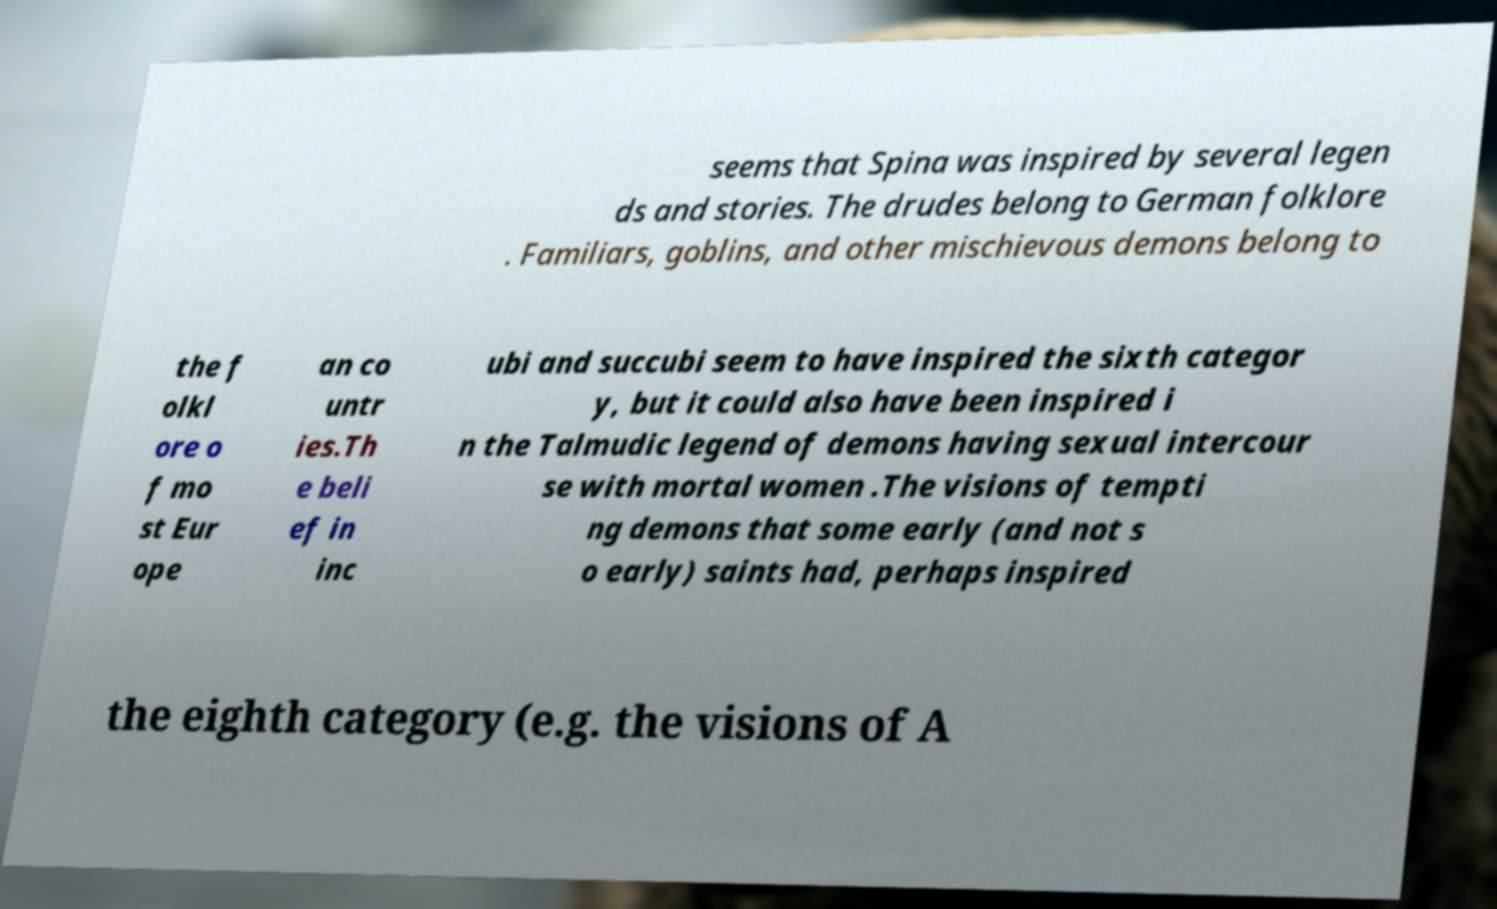I need the written content from this picture converted into text. Can you do that? seems that Spina was inspired by several legen ds and stories. The drudes belong to German folklore . Familiars, goblins, and other mischievous demons belong to the f olkl ore o f mo st Eur ope an co untr ies.Th e beli ef in inc ubi and succubi seem to have inspired the sixth categor y, but it could also have been inspired i n the Talmudic legend of demons having sexual intercour se with mortal women .The visions of tempti ng demons that some early (and not s o early) saints had, perhaps inspired the eighth category (e.g. the visions of A 